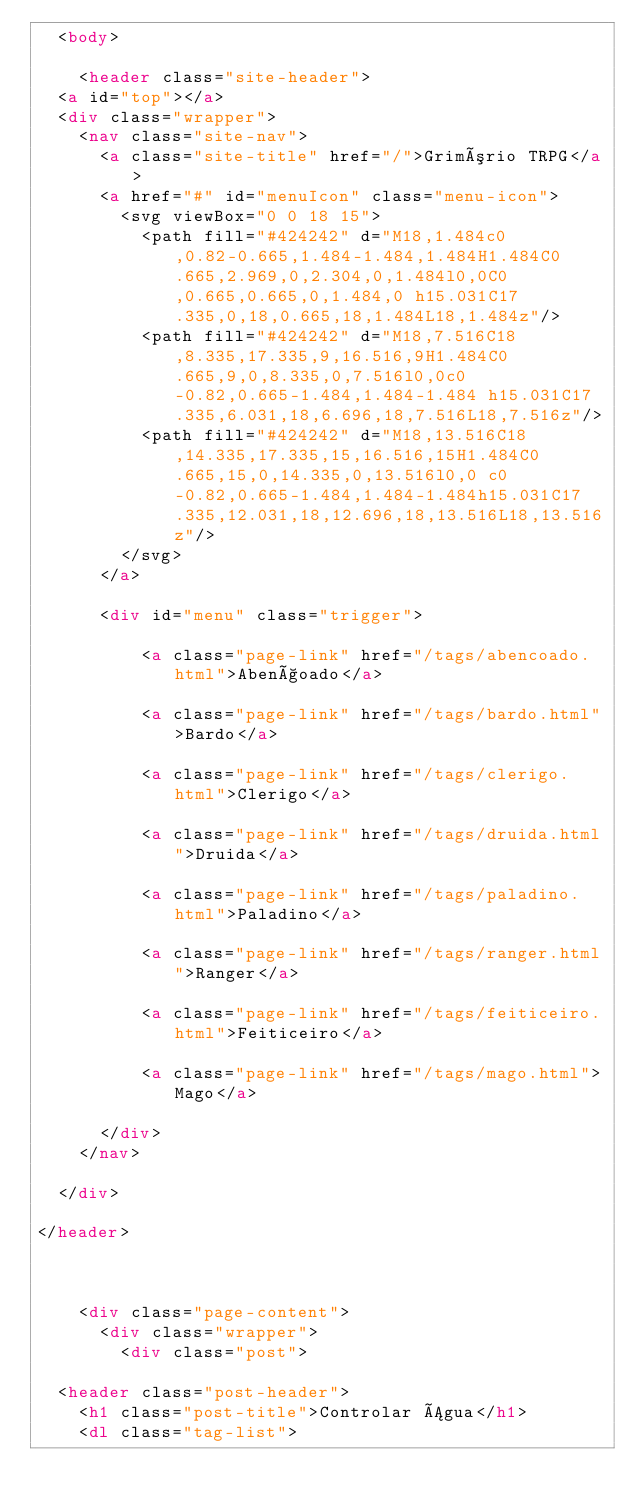Convert code to text. <code><loc_0><loc_0><loc_500><loc_500><_HTML_>  <body>

    <header class="site-header">
  <a id="top"></a>
  <div class="wrapper">
    <nav class="site-nav">
      <a class="site-title" href="/">Grimório TRPG</a>
      <a href="#" id="menuIcon" class="menu-icon">
        <svg viewBox="0 0 18 15">
          <path fill="#424242" d="M18,1.484c0,0.82-0.665,1.484-1.484,1.484H1.484C0.665,2.969,0,2.304,0,1.484l0,0C0,0.665,0.665,0,1.484,0 h15.031C17.335,0,18,0.665,18,1.484L18,1.484z"/>
          <path fill="#424242" d="M18,7.516C18,8.335,17.335,9,16.516,9H1.484C0.665,9,0,8.335,0,7.516l0,0c0-0.82,0.665-1.484,1.484-1.484 h15.031C17.335,6.031,18,6.696,18,7.516L18,7.516z"/>
          <path fill="#424242" d="M18,13.516C18,14.335,17.335,15,16.516,15H1.484C0.665,15,0,14.335,0,13.516l0,0 c0-0.82,0.665-1.484,1.484-1.484h15.031C17.335,12.031,18,12.696,18,13.516L18,13.516z"/>
        </svg>
      </a>

      <div id="menu" class="trigger">
        
          <a class="page-link" href="/tags/abencoado.html">Abençoado</a>
        
          <a class="page-link" href="/tags/bardo.html">Bardo</a>
        
          <a class="page-link" href="/tags/clerigo.html">Clerigo</a>
        
          <a class="page-link" href="/tags/druida.html">Druida</a>
        
          <a class="page-link" href="/tags/paladino.html">Paladino</a>
        
          <a class="page-link" href="/tags/ranger.html">Ranger</a>
        
          <a class="page-link" href="/tags/feiticeiro.html">Feiticeiro</a>
        
          <a class="page-link" href="/tags/mago.html">Mago</a>
        
      </div>
    </nav>

  </div>

</header>



    <div class="page-content">
      <div class="wrapper">
        <div class="post">

  <header class="post-header">
    <h1 class="post-title">Controlar Água</h1>
    <dl class="tag-list"></code> 